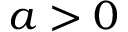Convert formula to latex. <formula><loc_0><loc_0><loc_500><loc_500>a > 0</formula> 